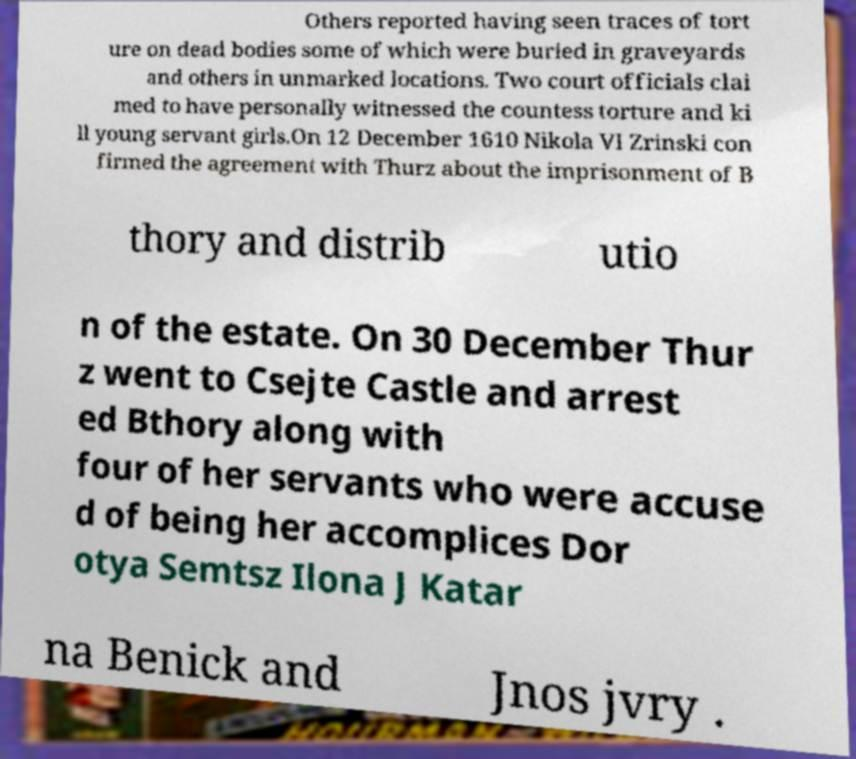I need the written content from this picture converted into text. Can you do that? Others reported having seen traces of tort ure on dead bodies some of which were buried in graveyards and others in unmarked locations. Two court officials clai med to have personally witnessed the countess torture and ki ll young servant girls.On 12 December 1610 Nikola VI Zrinski con firmed the agreement with Thurz about the imprisonment of B thory and distrib utio n of the estate. On 30 December Thur z went to Csejte Castle and arrest ed Bthory along with four of her servants who were accuse d of being her accomplices Dor otya Semtsz Ilona J Katar na Benick and Jnos jvry . 